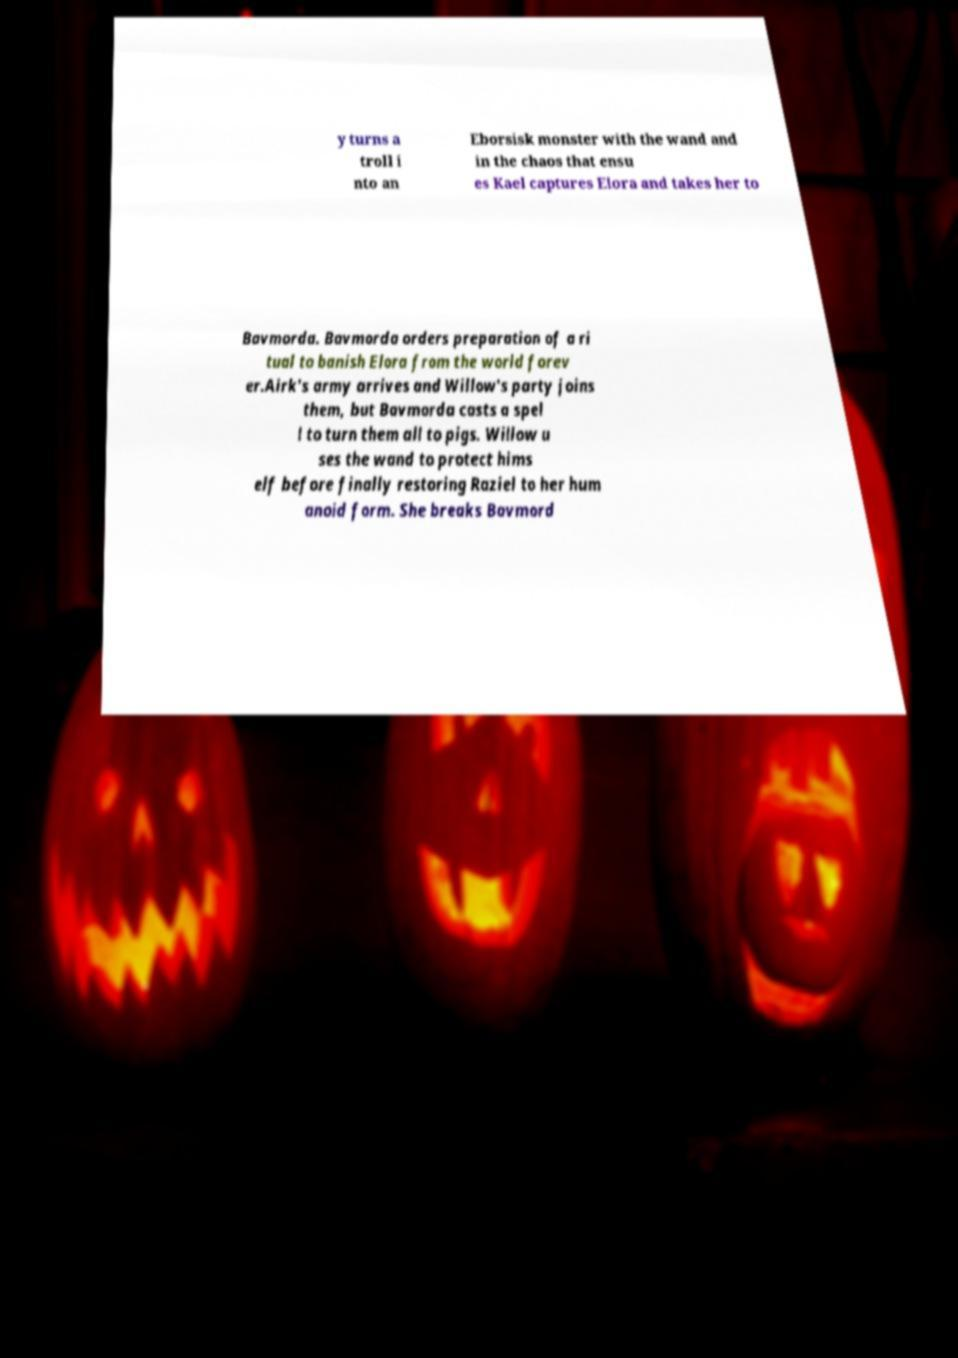For documentation purposes, I need the text within this image transcribed. Could you provide that? y turns a troll i nto an Eborsisk monster with the wand and in the chaos that ensu es Kael captures Elora and takes her to Bavmorda. Bavmorda orders preparation of a ri tual to banish Elora from the world forev er.Airk's army arrives and Willow's party joins them, but Bavmorda casts a spel l to turn them all to pigs. Willow u ses the wand to protect hims elf before finally restoring Raziel to her hum anoid form. She breaks Bavmord 